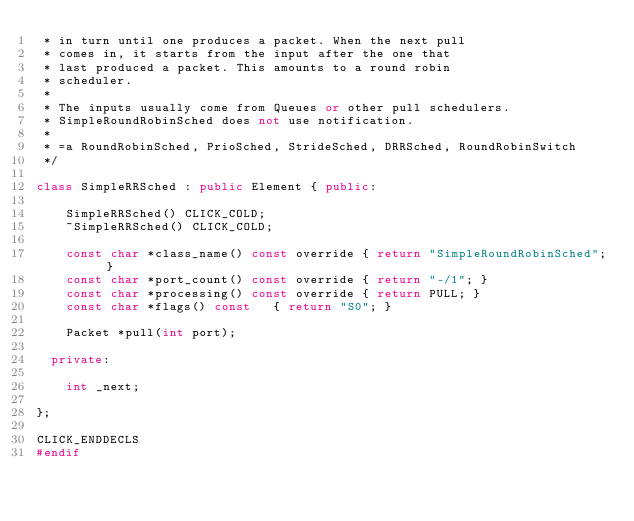Convert code to text. <code><loc_0><loc_0><loc_500><loc_500><_C++_> * in turn until one produces a packet. When the next pull
 * comes in, it starts from the input after the one that
 * last produced a packet. This amounts to a round robin
 * scheduler.
 *
 * The inputs usually come from Queues or other pull schedulers.
 * SimpleRoundRobinSched does not use notification.
 *
 * =a RoundRobinSched, PrioSched, StrideSched, DRRSched, RoundRobinSwitch
 */

class SimpleRRSched : public Element { public:

    SimpleRRSched() CLICK_COLD;
    ~SimpleRRSched() CLICK_COLD;

    const char *class_name() const override	{ return "SimpleRoundRobinSched"; }
    const char *port_count() const override	{ return "-/1"; }
    const char *processing() const override	{ return PULL; }
    const char *flags() const		{ return "S0"; }

    Packet *pull(int port);

  private:

    int _next;

};

CLICK_ENDDECLS
#endif
</code> 